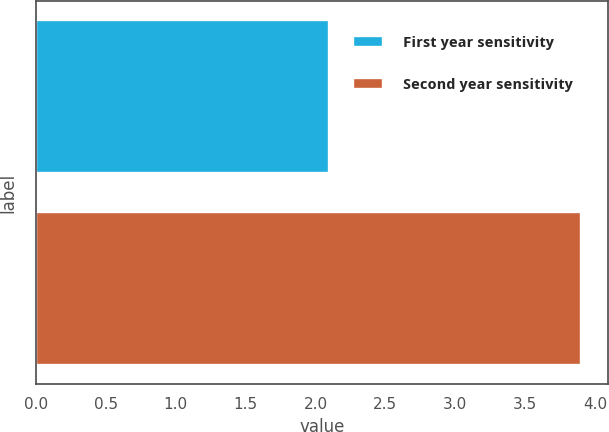Convert chart. <chart><loc_0><loc_0><loc_500><loc_500><bar_chart><fcel>First year sensitivity<fcel>Second year sensitivity<nl><fcel>2.1<fcel>3.9<nl></chart> 